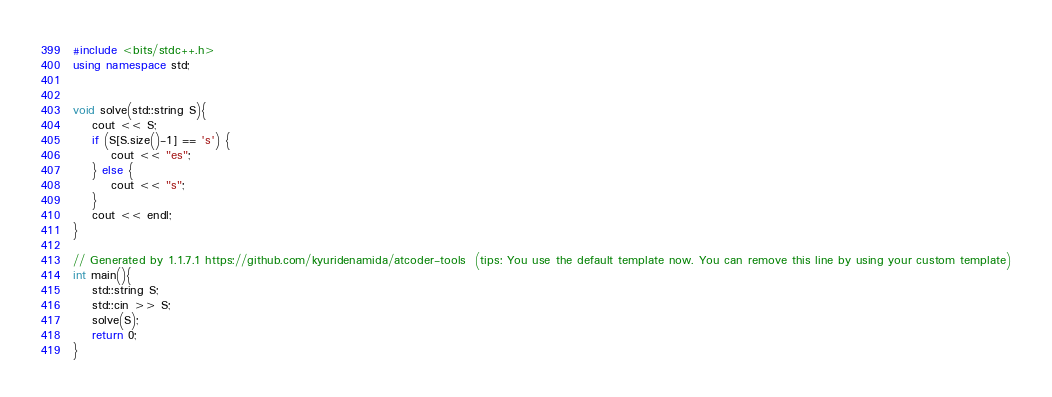Convert code to text. <code><loc_0><loc_0><loc_500><loc_500><_C++_>#include <bits/stdc++.h>
using namespace std;


void solve(std::string S){
    cout << S;
    if (S[S.size()-1] == 's') {
        cout << "es";
    } else {
        cout << "s";
    }
    cout << endl;
}

// Generated by 1.1.7.1 https://github.com/kyuridenamida/atcoder-tools  (tips: You use the default template now. You can remove this line by using your custom template)
int main(){
    std::string S;
    std::cin >> S;
    solve(S);
    return 0;
}
</code> 